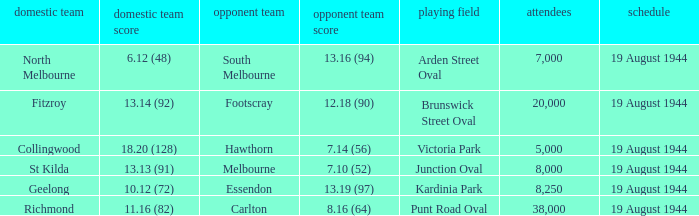What is Fitzroy's Home team Crowd? 20000.0. 